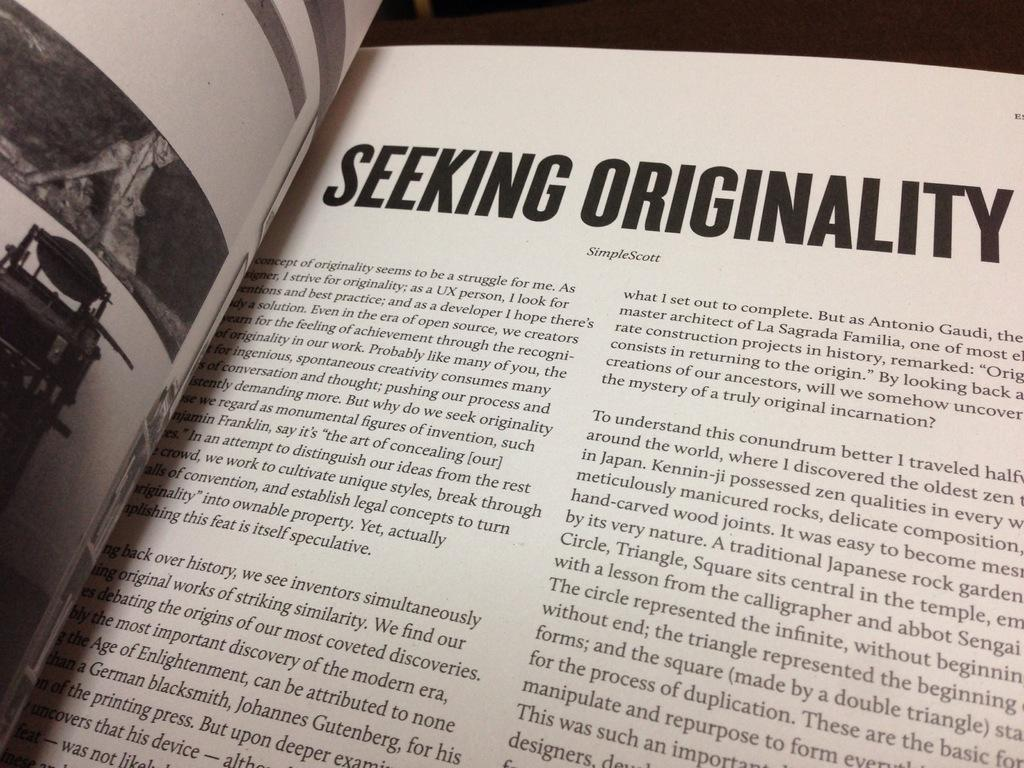<image>
Render a clear and concise summary of the photo. the book is opened to the seeking originality page 